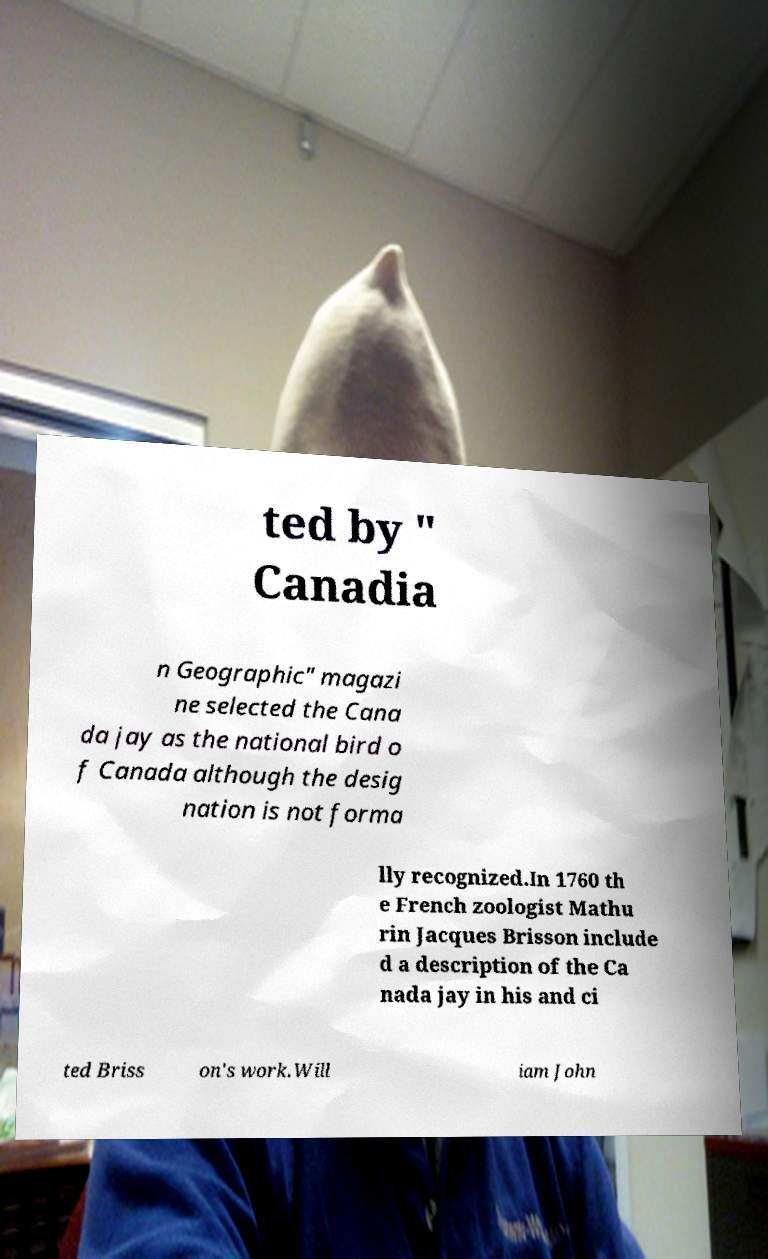Could you assist in decoding the text presented in this image and type it out clearly? ted by " Canadia n Geographic" magazi ne selected the Cana da jay as the national bird o f Canada although the desig nation is not forma lly recognized.In 1760 th e French zoologist Mathu rin Jacques Brisson include d a description of the Ca nada jay in his and ci ted Briss on's work.Will iam John 